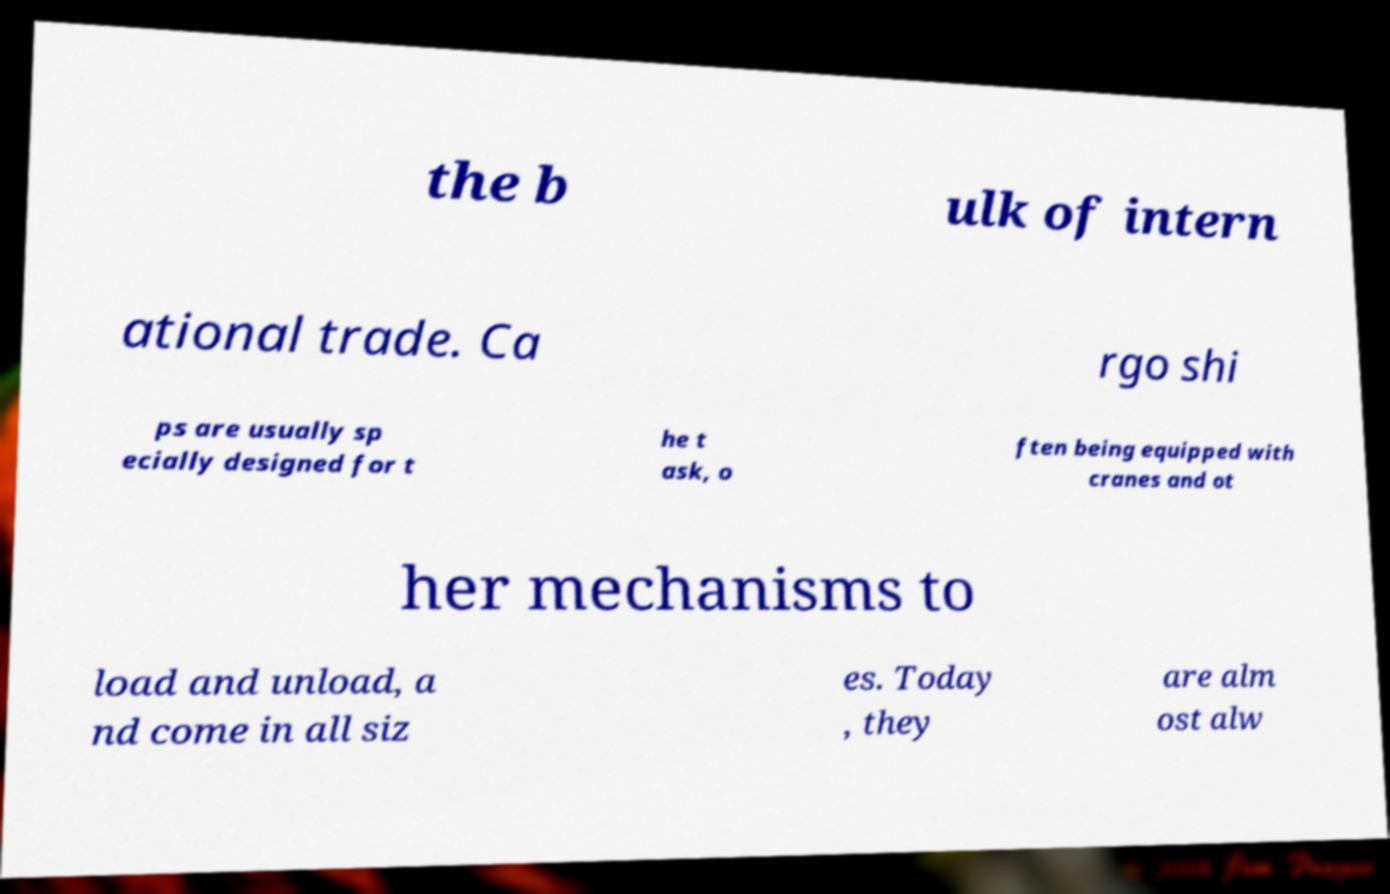Could you assist in decoding the text presented in this image and type it out clearly? the b ulk of intern ational trade. Ca rgo shi ps are usually sp ecially designed for t he t ask, o ften being equipped with cranes and ot her mechanisms to load and unload, a nd come in all siz es. Today , they are alm ost alw 